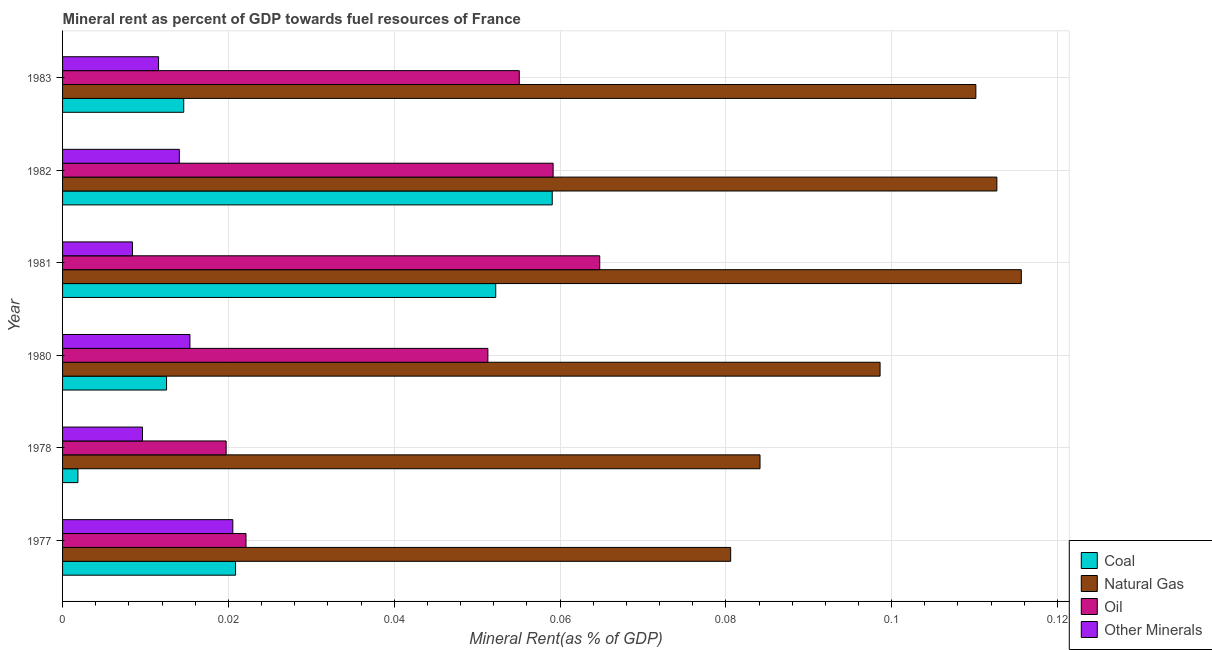How many groups of bars are there?
Provide a short and direct response. 6. Are the number of bars per tick equal to the number of legend labels?
Your response must be concise. Yes. Are the number of bars on each tick of the Y-axis equal?
Your response must be concise. Yes. How many bars are there on the 4th tick from the top?
Your response must be concise. 4. How many bars are there on the 4th tick from the bottom?
Your answer should be compact. 4. What is the oil rent in 1983?
Provide a succinct answer. 0.06. Across all years, what is the maximum coal rent?
Your answer should be very brief. 0.06. Across all years, what is the minimum natural gas rent?
Your response must be concise. 0.08. In which year was the natural gas rent maximum?
Provide a short and direct response. 1981. In which year was the oil rent minimum?
Provide a short and direct response. 1978. What is the total  rent of other minerals in the graph?
Offer a terse response. 0.08. What is the difference between the oil rent in 1977 and that in 1982?
Make the answer very short. -0.04. What is the difference between the oil rent in 1980 and the coal rent in 1983?
Provide a short and direct response. 0.04. What is the average oil rent per year?
Your response must be concise. 0.04. In the year 1983, what is the difference between the  rent of other minerals and oil rent?
Your response must be concise. -0.04. What is the ratio of the coal rent in 1982 to that in 1983?
Ensure brevity in your answer.  4.04. Is the coal rent in 1980 less than that in 1982?
Give a very brief answer. Yes. Is the difference between the oil rent in 1982 and 1983 greater than the difference between the natural gas rent in 1982 and 1983?
Your answer should be compact. Yes. What is the difference between the highest and the second highest natural gas rent?
Your response must be concise. 0. Is it the case that in every year, the sum of the oil rent and natural gas rent is greater than the sum of coal rent and  rent of other minerals?
Make the answer very short. No. What does the 3rd bar from the top in 1980 represents?
Provide a succinct answer. Natural Gas. What does the 1st bar from the bottom in 1980 represents?
Your response must be concise. Coal. Is it the case that in every year, the sum of the coal rent and natural gas rent is greater than the oil rent?
Your answer should be compact. Yes. How many bars are there?
Your response must be concise. 24. What is the difference between two consecutive major ticks on the X-axis?
Provide a short and direct response. 0.02. Are the values on the major ticks of X-axis written in scientific E-notation?
Provide a succinct answer. No. Does the graph contain grids?
Your response must be concise. Yes. Where does the legend appear in the graph?
Offer a very short reply. Bottom right. How many legend labels are there?
Make the answer very short. 4. How are the legend labels stacked?
Give a very brief answer. Vertical. What is the title of the graph?
Give a very brief answer. Mineral rent as percent of GDP towards fuel resources of France. Does "UNRWA" appear as one of the legend labels in the graph?
Keep it short and to the point. No. What is the label or title of the X-axis?
Offer a very short reply. Mineral Rent(as % of GDP). What is the Mineral Rent(as % of GDP) of Coal in 1977?
Your answer should be compact. 0.02. What is the Mineral Rent(as % of GDP) of Natural Gas in 1977?
Provide a short and direct response. 0.08. What is the Mineral Rent(as % of GDP) of Oil in 1977?
Give a very brief answer. 0.02. What is the Mineral Rent(as % of GDP) in Other Minerals in 1977?
Provide a succinct answer. 0.02. What is the Mineral Rent(as % of GDP) of Coal in 1978?
Your answer should be very brief. 0. What is the Mineral Rent(as % of GDP) of Natural Gas in 1978?
Provide a short and direct response. 0.08. What is the Mineral Rent(as % of GDP) of Oil in 1978?
Your response must be concise. 0.02. What is the Mineral Rent(as % of GDP) in Other Minerals in 1978?
Provide a short and direct response. 0.01. What is the Mineral Rent(as % of GDP) in Coal in 1980?
Offer a terse response. 0.01. What is the Mineral Rent(as % of GDP) in Natural Gas in 1980?
Offer a very short reply. 0.1. What is the Mineral Rent(as % of GDP) of Oil in 1980?
Provide a succinct answer. 0.05. What is the Mineral Rent(as % of GDP) of Other Minerals in 1980?
Your answer should be compact. 0.02. What is the Mineral Rent(as % of GDP) of Coal in 1981?
Provide a succinct answer. 0.05. What is the Mineral Rent(as % of GDP) in Natural Gas in 1981?
Give a very brief answer. 0.12. What is the Mineral Rent(as % of GDP) in Oil in 1981?
Your answer should be very brief. 0.06. What is the Mineral Rent(as % of GDP) of Other Minerals in 1981?
Your answer should be compact. 0.01. What is the Mineral Rent(as % of GDP) of Coal in 1982?
Offer a terse response. 0.06. What is the Mineral Rent(as % of GDP) of Natural Gas in 1982?
Your answer should be very brief. 0.11. What is the Mineral Rent(as % of GDP) in Oil in 1982?
Offer a terse response. 0.06. What is the Mineral Rent(as % of GDP) of Other Minerals in 1982?
Your answer should be compact. 0.01. What is the Mineral Rent(as % of GDP) in Coal in 1983?
Offer a very short reply. 0.01. What is the Mineral Rent(as % of GDP) of Natural Gas in 1983?
Your answer should be compact. 0.11. What is the Mineral Rent(as % of GDP) in Oil in 1983?
Your response must be concise. 0.06. What is the Mineral Rent(as % of GDP) of Other Minerals in 1983?
Provide a short and direct response. 0.01. Across all years, what is the maximum Mineral Rent(as % of GDP) in Coal?
Keep it short and to the point. 0.06. Across all years, what is the maximum Mineral Rent(as % of GDP) of Natural Gas?
Offer a very short reply. 0.12. Across all years, what is the maximum Mineral Rent(as % of GDP) of Oil?
Make the answer very short. 0.06. Across all years, what is the maximum Mineral Rent(as % of GDP) in Other Minerals?
Provide a short and direct response. 0.02. Across all years, what is the minimum Mineral Rent(as % of GDP) of Coal?
Your answer should be very brief. 0. Across all years, what is the minimum Mineral Rent(as % of GDP) in Natural Gas?
Ensure brevity in your answer.  0.08. Across all years, what is the minimum Mineral Rent(as % of GDP) in Oil?
Offer a terse response. 0.02. Across all years, what is the minimum Mineral Rent(as % of GDP) in Other Minerals?
Provide a succinct answer. 0.01. What is the total Mineral Rent(as % of GDP) in Coal in the graph?
Give a very brief answer. 0.16. What is the total Mineral Rent(as % of GDP) of Natural Gas in the graph?
Ensure brevity in your answer.  0.6. What is the total Mineral Rent(as % of GDP) in Oil in the graph?
Give a very brief answer. 0.27. What is the total Mineral Rent(as % of GDP) in Other Minerals in the graph?
Your response must be concise. 0.08. What is the difference between the Mineral Rent(as % of GDP) of Coal in 1977 and that in 1978?
Keep it short and to the point. 0.02. What is the difference between the Mineral Rent(as % of GDP) in Natural Gas in 1977 and that in 1978?
Your answer should be compact. -0. What is the difference between the Mineral Rent(as % of GDP) in Oil in 1977 and that in 1978?
Offer a very short reply. 0. What is the difference between the Mineral Rent(as % of GDP) in Other Minerals in 1977 and that in 1978?
Ensure brevity in your answer.  0.01. What is the difference between the Mineral Rent(as % of GDP) of Coal in 1977 and that in 1980?
Offer a very short reply. 0.01. What is the difference between the Mineral Rent(as % of GDP) in Natural Gas in 1977 and that in 1980?
Keep it short and to the point. -0.02. What is the difference between the Mineral Rent(as % of GDP) of Oil in 1977 and that in 1980?
Offer a terse response. -0.03. What is the difference between the Mineral Rent(as % of GDP) in Other Minerals in 1977 and that in 1980?
Offer a terse response. 0.01. What is the difference between the Mineral Rent(as % of GDP) in Coal in 1977 and that in 1981?
Provide a succinct answer. -0.03. What is the difference between the Mineral Rent(as % of GDP) of Natural Gas in 1977 and that in 1981?
Make the answer very short. -0.04. What is the difference between the Mineral Rent(as % of GDP) in Oil in 1977 and that in 1981?
Make the answer very short. -0.04. What is the difference between the Mineral Rent(as % of GDP) of Other Minerals in 1977 and that in 1981?
Your answer should be very brief. 0.01. What is the difference between the Mineral Rent(as % of GDP) in Coal in 1977 and that in 1982?
Your answer should be very brief. -0.04. What is the difference between the Mineral Rent(as % of GDP) of Natural Gas in 1977 and that in 1982?
Offer a very short reply. -0.03. What is the difference between the Mineral Rent(as % of GDP) of Oil in 1977 and that in 1982?
Ensure brevity in your answer.  -0.04. What is the difference between the Mineral Rent(as % of GDP) of Other Minerals in 1977 and that in 1982?
Keep it short and to the point. 0.01. What is the difference between the Mineral Rent(as % of GDP) in Coal in 1977 and that in 1983?
Offer a very short reply. 0.01. What is the difference between the Mineral Rent(as % of GDP) of Natural Gas in 1977 and that in 1983?
Make the answer very short. -0.03. What is the difference between the Mineral Rent(as % of GDP) in Oil in 1977 and that in 1983?
Make the answer very short. -0.03. What is the difference between the Mineral Rent(as % of GDP) in Other Minerals in 1977 and that in 1983?
Your answer should be very brief. 0.01. What is the difference between the Mineral Rent(as % of GDP) in Coal in 1978 and that in 1980?
Your response must be concise. -0.01. What is the difference between the Mineral Rent(as % of GDP) of Natural Gas in 1978 and that in 1980?
Ensure brevity in your answer.  -0.01. What is the difference between the Mineral Rent(as % of GDP) of Oil in 1978 and that in 1980?
Ensure brevity in your answer.  -0.03. What is the difference between the Mineral Rent(as % of GDP) of Other Minerals in 1978 and that in 1980?
Offer a very short reply. -0.01. What is the difference between the Mineral Rent(as % of GDP) of Coal in 1978 and that in 1981?
Your answer should be compact. -0.05. What is the difference between the Mineral Rent(as % of GDP) of Natural Gas in 1978 and that in 1981?
Give a very brief answer. -0.03. What is the difference between the Mineral Rent(as % of GDP) in Oil in 1978 and that in 1981?
Give a very brief answer. -0.05. What is the difference between the Mineral Rent(as % of GDP) in Other Minerals in 1978 and that in 1981?
Provide a succinct answer. 0. What is the difference between the Mineral Rent(as % of GDP) of Coal in 1978 and that in 1982?
Provide a short and direct response. -0.06. What is the difference between the Mineral Rent(as % of GDP) in Natural Gas in 1978 and that in 1982?
Provide a succinct answer. -0.03. What is the difference between the Mineral Rent(as % of GDP) in Oil in 1978 and that in 1982?
Your response must be concise. -0.04. What is the difference between the Mineral Rent(as % of GDP) of Other Minerals in 1978 and that in 1982?
Your answer should be compact. -0. What is the difference between the Mineral Rent(as % of GDP) in Coal in 1978 and that in 1983?
Give a very brief answer. -0.01. What is the difference between the Mineral Rent(as % of GDP) of Natural Gas in 1978 and that in 1983?
Your response must be concise. -0.03. What is the difference between the Mineral Rent(as % of GDP) of Oil in 1978 and that in 1983?
Your answer should be very brief. -0.04. What is the difference between the Mineral Rent(as % of GDP) of Other Minerals in 1978 and that in 1983?
Your response must be concise. -0. What is the difference between the Mineral Rent(as % of GDP) of Coal in 1980 and that in 1981?
Keep it short and to the point. -0.04. What is the difference between the Mineral Rent(as % of GDP) in Natural Gas in 1980 and that in 1981?
Make the answer very short. -0.02. What is the difference between the Mineral Rent(as % of GDP) of Oil in 1980 and that in 1981?
Provide a short and direct response. -0.01. What is the difference between the Mineral Rent(as % of GDP) in Other Minerals in 1980 and that in 1981?
Provide a succinct answer. 0.01. What is the difference between the Mineral Rent(as % of GDP) of Coal in 1980 and that in 1982?
Ensure brevity in your answer.  -0.05. What is the difference between the Mineral Rent(as % of GDP) in Natural Gas in 1980 and that in 1982?
Provide a succinct answer. -0.01. What is the difference between the Mineral Rent(as % of GDP) in Oil in 1980 and that in 1982?
Ensure brevity in your answer.  -0.01. What is the difference between the Mineral Rent(as % of GDP) in Other Minerals in 1980 and that in 1982?
Your response must be concise. 0. What is the difference between the Mineral Rent(as % of GDP) of Coal in 1980 and that in 1983?
Make the answer very short. -0. What is the difference between the Mineral Rent(as % of GDP) in Natural Gas in 1980 and that in 1983?
Provide a short and direct response. -0.01. What is the difference between the Mineral Rent(as % of GDP) in Oil in 1980 and that in 1983?
Make the answer very short. -0. What is the difference between the Mineral Rent(as % of GDP) in Other Minerals in 1980 and that in 1983?
Ensure brevity in your answer.  0. What is the difference between the Mineral Rent(as % of GDP) in Coal in 1981 and that in 1982?
Your answer should be compact. -0.01. What is the difference between the Mineral Rent(as % of GDP) in Natural Gas in 1981 and that in 1982?
Give a very brief answer. 0. What is the difference between the Mineral Rent(as % of GDP) of Oil in 1981 and that in 1982?
Make the answer very short. 0.01. What is the difference between the Mineral Rent(as % of GDP) in Other Minerals in 1981 and that in 1982?
Provide a short and direct response. -0.01. What is the difference between the Mineral Rent(as % of GDP) of Coal in 1981 and that in 1983?
Offer a terse response. 0.04. What is the difference between the Mineral Rent(as % of GDP) in Natural Gas in 1981 and that in 1983?
Ensure brevity in your answer.  0.01. What is the difference between the Mineral Rent(as % of GDP) in Oil in 1981 and that in 1983?
Your answer should be compact. 0.01. What is the difference between the Mineral Rent(as % of GDP) in Other Minerals in 1981 and that in 1983?
Offer a terse response. -0. What is the difference between the Mineral Rent(as % of GDP) in Coal in 1982 and that in 1983?
Make the answer very short. 0.04. What is the difference between the Mineral Rent(as % of GDP) of Natural Gas in 1982 and that in 1983?
Offer a very short reply. 0. What is the difference between the Mineral Rent(as % of GDP) of Oil in 1982 and that in 1983?
Provide a succinct answer. 0. What is the difference between the Mineral Rent(as % of GDP) in Other Minerals in 1982 and that in 1983?
Offer a very short reply. 0. What is the difference between the Mineral Rent(as % of GDP) in Coal in 1977 and the Mineral Rent(as % of GDP) in Natural Gas in 1978?
Keep it short and to the point. -0.06. What is the difference between the Mineral Rent(as % of GDP) of Coal in 1977 and the Mineral Rent(as % of GDP) of Oil in 1978?
Offer a very short reply. 0. What is the difference between the Mineral Rent(as % of GDP) in Coal in 1977 and the Mineral Rent(as % of GDP) in Other Minerals in 1978?
Keep it short and to the point. 0.01. What is the difference between the Mineral Rent(as % of GDP) of Natural Gas in 1977 and the Mineral Rent(as % of GDP) of Oil in 1978?
Give a very brief answer. 0.06. What is the difference between the Mineral Rent(as % of GDP) of Natural Gas in 1977 and the Mineral Rent(as % of GDP) of Other Minerals in 1978?
Your response must be concise. 0.07. What is the difference between the Mineral Rent(as % of GDP) in Oil in 1977 and the Mineral Rent(as % of GDP) in Other Minerals in 1978?
Provide a succinct answer. 0.01. What is the difference between the Mineral Rent(as % of GDP) in Coal in 1977 and the Mineral Rent(as % of GDP) in Natural Gas in 1980?
Provide a short and direct response. -0.08. What is the difference between the Mineral Rent(as % of GDP) in Coal in 1977 and the Mineral Rent(as % of GDP) in Oil in 1980?
Offer a very short reply. -0.03. What is the difference between the Mineral Rent(as % of GDP) in Coal in 1977 and the Mineral Rent(as % of GDP) in Other Minerals in 1980?
Your answer should be very brief. 0.01. What is the difference between the Mineral Rent(as % of GDP) of Natural Gas in 1977 and the Mineral Rent(as % of GDP) of Oil in 1980?
Offer a very short reply. 0.03. What is the difference between the Mineral Rent(as % of GDP) of Natural Gas in 1977 and the Mineral Rent(as % of GDP) of Other Minerals in 1980?
Make the answer very short. 0.07. What is the difference between the Mineral Rent(as % of GDP) of Oil in 1977 and the Mineral Rent(as % of GDP) of Other Minerals in 1980?
Offer a very short reply. 0.01. What is the difference between the Mineral Rent(as % of GDP) in Coal in 1977 and the Mineral Rent(as % of GDP) in Natural Gas in 1981?
Provide a short and direct response. -0.09. What is the difference between the Mineral Rent(as % of GDP) in Coal in 1977 and the Mineral Rent(as % of GDP) in Oil in 1981?
Your response must be concise. -0.04. What is the difference between the Mineral Rent(as % of GDP) in Coal in 1977 and the Mineral Rent(as % of GDP) in Other Minerals in 1981?
Make the answer very short. 0.01. What is the difference between the Mineral Rent(as % of GDP) in Natural Gas in 1977 and the Mineral Rent(as % of GDP) in Oil in 1981?
Provide a succinct answer. 0.02. What is the difference between the Mineral Rent(as % of GDP) of Natural Gas in 1977 and the Mineral Rent(as % of GDP) of Other Minerals in 1981?
Your answer should be compact. 0.07. What is the difference between the Mineral Rent(as % of GDP) of Oil in 1977 and the Mineral Rent(as % of GDP) of Other Minerals in 1981?
Give a very brief answer. 0.01. What is the difference between the Mineral Rent(as % of GDP) in Coal in 1977 and the Mineral Rent(as % of GDP) in Natural Gas in 1982?
Your answer should be compact. -0.09. What is the difference between the Mineral Rent(as % of GDP) in Coal in 1977 and the Mineral Rent(as % of GDP) in Oil in 1982?
Keep it short and to the point. -0.04. What is the difference between the Mineral Rent(as % of GDP) of Coal in 1977 and the Mineral Rent(as % of GDP) of Other Minerals in 1982?
Offer a terse response. 0.01. What is the difference between the Mineral Rent(as % of GDP) of Natural Gas in 1977 and the Mineral Rent(as % of GDP) of Oil in 1982?
Give a very brief answer. 0.02. What is the difference between the Mineral Rent(as % of GDP) of Natural Gas in 1977 and the Mineral Rent(as % of GDP) of Other Minerals in 1982?
Your response must be concise. 0.07. What is the difference between the Mineral Rent(as % of GDP) in Oil in 1977 and the Mineral Rent(as % of GDP) in Other Minerals in 1982?
Make the answer very short. 0.01. What is the difference between the Mineral Rent(as % of GDP) in Coal in 1977 and the Mineral Rent(as % of GDP) in Natural Gas in 1983?
Provide a succinct answer. -0.09. What is the difference between the Mineral Rent(as % of GDP) of Coal in 1977 and the Mineral Rent(as % of GDP) of Oil in 1983?
Your answer should be compact. -0.03. What is the difference between the Mineral Rent(as % of GDP) of Coal in 1977 and the Mineral Rent(as % of GDP) of Other Minerals in 1983?
Your answer should be compact. 0.01. What is the difference between the Mineral Rent(as % of GDP) in Natural Gas in 1977 and the Mineral Rent(as % of GDP) in Oil in 1983?
Keep it short and to the point. 0.03. What is the difference between the Mineral Rent(as % of GDP) of Natural Gas in 1977 and the Mineral Rent(as % of GDP) of Other Minerals in 1983?
Your answer should be compact. 0.07. What is the difference between the Mineral Rent(as % of GDP) of Oil in 1977 and the Mineral Rent(as % of GDP) of Other Minerals in 1983?
Make the answer very short. 0.01. What is the difference between the Mineral Rent(as % of GDP) in Coal in 1978 and the Mineral Rent(as % of GDP) in Natural Gas in 1980?
Ensure brevity in your answer.  -0.1. What is the difference between the Mineral Rent(as % of GDP) in Coal in 1978 and the Mineral Rent(as % of GDP) in Oil in 1980?
Give a very brief answer. -0.05. What is the difference between the Mineral Rent(as % of GDP) in Coal in 1978 and the Mineral Rent(as % of GDP) in Other Minerals in 1980?
Provide a short and direct response. -0.01. What is the difference between the Mineral Rent(as % of GDP) in Natural Gas in 1978 and the Mineral Rent(as % of GDP) in Oil in 1980?
Ensure brevity in your answer.  0.03. What is the difference between the Mineral Rent(as % of GDP) of Natural Gas in 1978 and the Mineral Rent(as % of GDP) of Other Minerals in 1980?
Provide a succinct answer. 0.07. What is the difference between the Mineral Rent(as % of GDP) in Oil in 1978 and the Mineral Rent(as % of GDP) in Other Minerals in 1980?
Your answer should be compact. 0. What is the difference between the Mineral Rent(as % of GDP) of Coal in 1978 and the Mineral Rent(as % of GDP) of Natural Gas in 1981?
Your answer should be compact. -0.11. What is the difference between the Mineral Rent(as % of GDP) of Coal in 1978 and the Mineral Rent(as % of GDP) of Oil in 1981?
Give a very brief answer. -0.06. What is the difference between the Mineral Rent(as % of GDP) of Coal in 1978 and the Mineral Rent(as % of GDP) of Other Minerals in 1981?
Ensure brevity in your answer.  -0.01. What is the difference between the Mineral Rent(as % of GDP) in Natural Gas in 1978 and the Mineral Rent(as % of GDP) in Oil in 1981?
Provide a succinct answer. 0.02. What is the difference between the Mineral Rent(as % of GDP) of Natural Gas in 1978 and the Mineral Rent(as % of GDP) of Other Minerals in 1981?
Make the answer very short. 0.08. What is the difference between the Mineral Rent(as % of GDP) of Oil in 1978 and the Mineral Rent(as % of GDP) of Other Minerals in 1981?
Ensure brevity in your answer.  0.01. What is the difference between the Mineral Rent(as % of GDP) in Coal in 1978 and the Mineral Rent(as % of GDP) in Natural Gas in 1982?
Offer a very short reply. -0.11. What is the difference between the Mineral Rent(as % of GDP) of Coal in 1978 and the Mineral Rent(as % of GDP) of Oil in 1982?
Provide a short and direct response. -0.06. What is the difference between the Mineral Rent(as % of GDP) in Coal in 1978 and the Mineral Rent(as % of GDP) in Other Minerals in 1982?
Offer a very short reply. -0.01. What is the difference between the Mineral Rent(as % of GDP) in Natural Gas in 1978 and the Mineral Rent(as % of GDP) in Oil in 1982?
Your response must be concise. 0.03. What is the difference between the Mineral Rent(as % of GDP) of Natural Gas in 1978 and the Mineral Rent(as % of GDP) of Other Minerals in 1982?
Give a very brief answer. 0.07. What is the difference between the Mineral Rent(as % of GDP) in Oil in 1978 and the Mineral Rent(as % of GDP) in Other Minerals in 1982?
Provide a succinct answer. 0.01. What is the difference between the Mineral Rent(as % of GDP) of Coal in 1978 and the Mineral Rent(as % of GDP) of Natural Gas in 1983?
Offer a very short reply. -0.11. What is the difference between the Mineral Rent(as % of GDP) of Coal in 1978 and the Mineral Rent(as % of GDP) of Oil in 1983?
Provide a succinct answer. -0.05. What is the difference between the Mineral Rent(as % of GDP) of Coal in 1978 and the Mineral Rent(as % of GDP) of Other Minerals in 1983?
Your response must be concise. -0.01. What is the difference between the Mineral Rent(as % of GDP) in Natural Gas in 1978 and the Mineral Rent(as % of GDP) in Oil in 1983?
Your answer should be very brief. 0.03. What is the difference between the Mineral Rent(as % of GDP) in Natural Gas in 1978 and the Mineral Rent(as % of GDP) in Other Minerals in 1983?
Ensure brevity in your answer.  0.07. What is the difference between the Mineral Rent(as % of GDP) of Oil in 1978 and the Mineral Rent(as % of GDP) of Other Minerals in 1983?
Keep it short and to the point. 0.01. What is the difference between the Mineral Rent(as % of GDP) of Coal in 1980 and the Mineral Rent(as % of GDP) of Natural Gas in 1981?
Ensure brevity in your answer.  -0.1. What is the difference between the Mineral Rent(as % of GDP) in Coal in 1980 and the Mineral Rent(as % of GDP) in Oil in 1981?
Give a very brief answer. -0.05. What is the difference between the Mineral Rent(as % of GDP) of Coal in 1980 and the Mineral Rent(as % of GDP) of Other Minerals in 1981?
Your answer should be compact. 0. What is the difference between the Mineral Rent(as % of GDP) in Natural Gas in 1980 and the Mineral Rent(as % of GDP) in Oil in 1981?
Your answer should be compact. 0.03. What is the difference between the Mineral Rent(as % of GDP) of Natural Gas in 1980 and the Mineral Rent(as % of GDP) of Other Minerals in 1981?
Your answer should be compact. 0.09. What is the difference between the Mineral Rent(as % of GDP) in Oil in 1980 and the Mineral Rent(as % of GDP) in Other Minerals in 1981?
Your response must be concise. 0.04. What is the difference between the Mineral Rent(as % of GDP) of Coal in 1980 and the Mineral Rent(as % of GDP) of Natural Gas in 1982?
Ensure brevity in your answer.  -0.1. What is the difference between the Mineral Rent(as % of GDP) of Coal in 1980 and the Mineral Rent(as % of GDP) of Oil in 1982?
Make the answer very short. -0.05. What is the difference between the Mineral Rent(as % of GDP) of Coal in 1980 and the Mineral Rent(as % of GDP) of Other Minerals in 1982?
Offer a terse response. -0. What is the difference between the Mineral Rent(as % of GDP) of Natural Gas in 1980 and the Mineral Rent(as % of GDP) of Oil in 1982?
Ensure brevity in your answer.  0.04. What is the difference between the Mineral Rent(as % of GDP) of Natural Gas in 1980 and the Mineral Rent(as % of GDP) of Other Minerals in 1982?
Your answer should be very brief. 0.08. What is the difference between the Mineral Rent(as % of GDP) of Oil in 1980 and the Mineral Rent(as % of GDP) of Other Minerals in 1982?
Give a very brief answer. 0.04. What is the difference between the Mineral Rent(as % of GDP) in Coal in 1980 and the Mineral Rent(as % of GDP) in Natural Gas in 1983?
Your answer should be compact. -0.1. What is the difference between the Mineral Rent(as % of GDP) of Coal in 1980 and the Mineral Rent(as % of GDP) of Oil in 1983?
Provide a succinct answer. -0.04. What is the difference between the Mineral Rent(as % of GDP) in Natural Gas in 1980 and the Mineral Rent(as % of GDP) in Oil in 1983?
Offer a very short reply. 0.04. What is the difference between the Mineral Rent(as % of GDP) in Natural Gas in 1980 and the Mineral Rent(as % of GDP) in Other Minerals in 1983?
Offer a very short reply. 0.09. What is the difference between the Mineral Rent(as % of GDP) of Oil in 1980 and the Mineral Rent(as % of GDP) of Other Minerals in 1983?
Your answer should be very brief. 0.04. What is the difference between the Mineral Rent(as % of GDP) in Coal in 1981 and the Mineral Rent(as % of GDP) in Natural Gas in 1982?
Your response must be concise. -0.06. What is the difference between the Mineral Rent(as % of GDP) in Coal in 1981 and the Mineral Rent(as % of GDP) in Oil in 1982?
Give a very brief answer. -0.01. What is the difference between the Mineral Rent(as % of GDP) of Coal in 1981 and the Mineral Rent(as % of GDP) of Other Minerals in 1982?
Offer a very short reply. 0.04. What is the difference between the Mineral Rent(as % of GDP) in Natural Gas in 1981 and the Mineral Rent(as % of GDP) in Oil in 1982?
Offer a terse response. 0.06. What is the difference between the Mineral Rent(as % of GDP) of Natural Gas in 1981 and the Mineral Rent(as % of GDP) of Other Minerals in 1982?
Your response must be concise. 0.1. What is the difference between the Mineral Rent(as % of GDP) of Oil in 1981 and the Mineral Rent(as % of GDP) of Other Minerals in 1982?
Give a very brief answer. 0.05. What is the difference between the Mineral Rent(as % of GDP) in Coal in 1981 and the Mineral Rent(as % of GDP) in Natural Gas in 1983?
Offer a terse response. -0.06. What is the difference between the Mineral Rent(as % of GDP) of Coal in 1981 and the Mineral Rent(as % of GDP) of Oil in 1983?
Your answer should be compact. -0. What is the difference between the Mineral Rent(as % of GDP) in Coal in 1981 and the Mineral Rent(as % of GDP) in Other Minerals in 1983?
Provide a succinct answer. 0.04. What is the difference between the Mineral Rent(as % of GDP) in Natural Gas in 1981 and the Mineral Rent(as % of GDP) in Oil in 1983?
Your answer should be very brief. 0.06. What is the difference between the Mineral Rent(as % of GDP) of Natural Gas in 1981 and the Mineral Rent(as % of GDP) of Other Minerals in 1983?
Offer a terse response. 0.1. What is the difference between the Mineral Rent(as % of GDP) of Oil in 1981 and the Mineral Rent(as % of GDP) of Other Minerals in 1983?
Your answer should be compact. 0.05. What is the difference between the Mineral Rent(as % of GDP) of Coal in 1982 and the Mineral Rent(as % of GDP) of Natural Gas in 1983?
Provide a short and direct response. -0.05. What is the difference between the Mineral Rent(as % of GDP) in Coal in 1982 and the Mineral Rent(as % of GDP) in Oil in 1983?
Keep it short and to the point. 0. What is the difference between the Mineral Rent(as % of GDP) in Coal in 1982 and the Mineral Rent(as % of GDP) in Other Minerals in 1983?
Your answer should be very brief. 0.05. What is the difference between the Mineral Rent(as % of GDP) in Natural Gas in 1982 and the Mineral Rent(as % of GDP) in Oil in 1983?
Give a very brief answer. 0.06. What is the difference between the Mineral Rent(as % of GDP) in Natural Gas in 1982 and the Mineral Rent(as % of GDP) in Other Minerals in 1983?
Provide a short and direct response. 0.1. What is the difference between the Mineral Rent(as % of GDP) of Oil in 1982 and the Mineral Rent(as % of GDP) of Other Minerals in 1983?
Your answer should be very brief. 0.05. What is the average Mineral Rent(as % of GDP) of Coal per year?
Offer a terse response. 0.03. What is the average Mineral Rent(as % of GDP) of Natural Gas per year?
Your answer should be very brief. 0.1. What is the average Mineral Rent(as % of GDP) of Oil per year?
Your response must be concise. 0.05. What is the average Mineral Rent(as % of GDP) of Other Minerals per year?
Give a very brief answer. 0.01. In the year 1977, what is the difference between the Mineral Rent(as % of GDP) of Coal and Mineral Rent(as % of GDP) of Natural Gas?
Offer a very short reply. -0.06. In the year 1977, what is the difference between the Mineral Rent(as % of GDP) of Coal and Mineral Rent(as % of GDP) of Oil?
Your answer should be very brief. -0. In the year 1977, what is the difference between the Mineral Rent(as % of GDP) in Natural Gas and Mineral Rent(as % of GDP) in Oil?
Your answer should be compact. 0.06. In the year 1977, what is the difference between the Mineral Rent(as % of GDP) in Natural Gas and Mineral Rent(as % of GDP) in Other Minerals?
Ensure brevity in your answer.  0.06. In the year 1977, what is the difference between the Mineral Rent(as % of GDP) in Oil and Mineral Rent(as % of GDP) in Other Minerals?
Your answer should be compact. 0. In the year 1978, what is the difference between the Mineral Rent(as % of GDP) in Coal and Mineral Rent(as % of GDP) in Natural Gas?
Make the answer very short. -0.08. In the year 1978, what is the difference between the Mineral Rent(as % of GDP) of Coal and Mineral Rent(as % of GDP) of Oil?
Your answer should be compact. -0.02. In the year 1978, what is the difference between the Mineral Rent(as % of GDP) of Coal and Mineral Rent(as % of GDP) of Other Minerals?
Provide a succinct answer. -0.01. In the year 1978, what is the difference between the Mineral Rent(as % of GDP) of Natural Gas and Mineral Rent(as % of GDP) of Oil?
Ensure brevity in your answer.  0.06. In the year 1978, what is the difference between the Mineral Rent(as % of GDP) of Natural Gas and Mineral Rent(as % of GDP) of Other Minerals?
Keep it short and to the point. 0.07. In the year 1978, what is the difference between the Mineral Rent(as % of GDP) of Oil and Mineral Rent(as % of GDP) of Other Minerals?
Your response must be concise. 0.01. In the year 1980, what is the difference between the Mineral Rent(as % of GDP) in Coal and Mineral Rent(as % of GDP) in Natural Gas?
Offer a very short reply. -0.09. In the year 1980, what is the difference between the Mineral Rent(as % of GDP) of Coal and Mineral Rent(as % of GDP) of Oil?
Make the answer very short. -0.04. In the year 1980, what is the difference between the Mineral Rent(as % of GDP) of Coal and Mineral Rent(as % of GDP) of Other Minerals?
Provide a short and direct response. -0. In the year 1980, what is the difference between the Mineral Rent(as % of GDP) in Natural Gas and Mineral Rent(as % of GDP) in Oil?
Your answer should be very brief. 0.05. In the year 1980, what is the difference between the Mineral Rent(as % of GDP) of Natural Gas and Mineral Rent(as % of GDP) of Other Minerals?
Ensure brevity in your answer.  0.08. In the year 1980, what is the difference between the Mineral Rent(as % of GDP) in Oil and Mineral Rent(as % of GDP) in Other Minerals?
Your response must be concise. 0.04. In the year 1981, what is the difference between the Mineral Rent(as % of GDP) of Coal and Mineral Rent(as % of GDP) of Natural Gas?
Offer a terse response. -0.06. In the year 1981, what is the difference between the Mineral Rent(as % of GDP) of Coal and Mineral Rent(as % of GDP) of Oil?
Ensure brevity in your answer.  -0.01. In the year 1981, what is the difference between the Mineral Rent(as % of GDP) of Coal and Mineral Rent(as % of GDP) of Other Minerals?
Offer a terse response. 0.04. In the year 1981, what is the difference between the Mineral Rent(as % of GDP) in Natural Gas and Mineral Rent(as % of GDP) in Oil?
Provide a short and direct response. 0.05. In the year 1981, what is the difference between the Mineral Rent(as % of GDP) in Natural Gas and Mineral Rent(as % of GDP) in Other Minerals?
Your answer should be compact. 0.11. In the year 1981, what is the difference between the Mineral Rent(as % of GDP) of Oil and Mineral Rent(as % of GDP) of Other Minerals?
Your response must be concise. 0.06. In the year 1982, what is the difference between the Mineral Rent(as % of GDP) of Coal and Mineral Rent(as % of GDP) of Natural Gas?
Offer a very short reply. -0.05. In the year 1982, what is the difference between the Mineral Rent(as % of GDP) in Coal and Mineral Rent(as % of GDP) in Oil?
Your answer should be compact. -0. In the year 1982, what is the difference between the Mineral Rent(as % of GDP) of Coal and Mineral Rent(as % of GDP) of Other Minerals?
Your answer should be compact. 0.04. In the year 1982, what is the difference between the Mineral Rent(as % of GDP) of Natural Gas and Mineral Rent(as % of GDP) of Oil?
Give a very brief answer. 0.05. In the year 1982, what is the difference between the Mineral Rent(as % of GDP) of Natural Gas and Mineral Rent(as % of GDP) of Other Minerals?
Provide a succinct answer. 0.1. In the year 1982, what is the difference between the Mineral Rent(as % of GDP) in Oil and Mineral Rent(as % of GDP) in Other Minerals?
Your response must be concise. 0.05. In the year 1983, what is the difference between the Mineral Rent(as % of GDP) of Coal and Mineral Rent(as % of GDP) of Natural Gas?
Offer a terse response. -0.1. In the year 1983, what is the difference between the Mineral Rent(as % of GDP) of Coal and Mineral Rent(as % of GDP) of Oil?
Keep it short and to the point. -0.04. In the year 1983, what is the difference between the Mineral Rent(as % of GDP) in Coal and Mineral Rent(as % of GDP) in Other Minerals?
Your answer should be compact. 0. In the year 1983, what is the difference between the Mineral Rent(as % of GDP) in Natural Gas and Mineral Rent(as % of GDP) in Oil?
Provide a short and direct response. 0.06. In the year 1983, what is the difference between the Mineral Rent(as % of GDP) in Natural Gas and Mineral Rent(as % of GDP) in Other Minerals?
Ensure brevity in your answer.  0.1. In the year 1983, what is the difference between the Mineral Rent(as % of GDP) of Oil and Mineral Rent(as % of GDP) of Other Minerals?
Ensure brevity in your answer.  0.04. What is the ratio of the Mineral Rent(as % of GDP) of Coal in 1977 to that in 1978?
Keep it short and to the point. 11.27. What is the ratio of the Mineral Rent(as % of GDP) of Natural Gas in 1977 to that in 1978?
Offer a very short reply. 0.96. What is the ratio of the Mineral Rent(as % of GDP) of Oil in 1977 to that in 1978?
Keep it short and to the point. 1.12. What is the ratio of the Mineral Rent(as % of GDP) in Other Minerals in 1977 to that in 1978?
Provide a succinct answer. 2.13. What is the ratio of the Mineral Rent(as % of GDP) of Coal in 1977 to that in 1980?
Your response must be concise. 1.66. What is the ratio of the Mineral Rent(as % of GDP) of Natural Gas in 1977 to that in 1980?
Make the answer very short. 0.82. What is the ratio of the Mineral Rent(as % of GDP) in Oil in 1977 to that in 1980?
Offer a very short reply. 0.43. What is the ratio of the Mineral Rent(as % of GDP) of Other Minerals in 1977 to that in 1980?
Your answer should be compact. 1.34. What is the ratio of the Mineral Rent(as % of GDP) of Coal in 1977 to that in 1981?
Your response must be concise. 0.4. What is the ratio of the Mineral Rent(as % of GDP) in Natural Gas in 1977 to that in 1981?
Keep it short and to the point. 0.7. What is the ratio of the Mineral Rent(as % of GDP) in Oil in 1977 to that in 1981?
Provide a short and direct response. 0.34. What is the ratio of the Mineral Rent(as % of GDP) in Other Minerals in 1977 to that in 1981?
Your response must be concise. 2.44. What is the ratio of the Mineral Rent(as % of GDP) of Coal in 1977 to that in 1982?
Your response must be concise. 0.35. What is the ratio of the Mineral Rent(as % of GDP) in Natural Gas in 1977 to that in 1982?
Your answer should be very brief. 0.72. What is the ratio of the Mineral Rent(as % of GDP) in Oil in 1977 to that in 1982?
Make the answer very short. 0.37. What is the ratio of the Mineral Rent(as % of GDP) in Other Minerals in 1977 to that in 1982?
Make the answer very short. 1.46. What is the ratio of the Mineral Rent(as % of GDP) of Coal in 1977 to that in 1983?
Provide a short and direct response. 1.43. What is the ratio of the Mineral Rent(as % of GDP) of Natural Gas in 1977 to that in 1983?
Make the answer very short. 0.73. What is the ratio of the Mineral Rent(as % of GDP) of Oil in 1977 to that in 1983?
Your response must be concise. 0.4. What is the ratio of the Mineral Rent(as % of GDP) of Other Minerals in 1977 to that in 1983?
Offer a very short reply. 1.77. What is the ratio of the Mineral Rent(as % of GDP) of Coal in 1978 to that in 1980?
Your answer should be compact. 0.15. What is the ratio of the Mineral Rent(as % of GDP) of Natural Gas in 1978 to that in 1980?
Provide a short and direct response. 0.85. What is the ratio of the Mineral Rent(as % of GDP) of Oil in 1978 to that in 1980?
Provide a short and direct response. 0.38. What is the ratio of the Mineral Rent(as % of GDP) in Other Minerals in 1978 to that in 1980?
Your answer should be compact. 0.63. What is the ratio of the Mineral Rent(as % of GDP) of Coal in 1978 to that in 1981?
Your answer should be compact. 0.04. What is the ratio of the Mineral Rent(as % of GDP) in Natural Gas in 1978 to that in 1981?
Your answer should be very brief. 0.73. What is the ratio of the Mineral Rent(as % of GDP) in Oil in 1978 to that in 1981?
Offer a very short reply. 0.3. What is the ratio of the Mineral Rent(as % of GDP) in Other Minerals in 1978 to that in 1981?
Ensure brevity in your answer.  1.14. What is the ratio of the Mineral Rent(as % of GDP) in Coal in 1978 to that in 1982?
Offer a very short reply. 0.03. What is the ratio of the Mineral Rent(as % of GDP) of Natural Gas in 1978 to that in 1982?
Your answer should be very brief. 0.75. What is the ratio of the Mineral Rent(as % of GDP) of Oil in 1978 to that in 1982?
Ensure brevity in your answer.  0.33. What is the ratio of the Mineral Rent(as % of GDP) of Other Minerals in 1978 to that in 1982?
Give a very brief answer. 0.68. What is the ratio of the Mineral Rent(as % of GDP) in Coal in 1978 to that in 1983?
Your answer should be very brief. 0.13. What is the ratio of the Mineral Rent(as % of GDP) of Natural Gas in 1978 to that in 1983?
Offer a very short reply. 0.76. What is the ratio of the Mineral Rent(as % of GDP) in Oil in 1978 to that in 1983?
Provide a succinct answer. 0.36. What is the ratio of the Mineral Rent(as % of GDP) in Other Minerals in 1978 to that in 1983?
Keep it short and to the point. 0.83. What is the ratio of the Mineral Rent(as % of GDP) of Coal in 1980 to that in 1981?
Give a very brief answer. 0.24. What is the ratio of the Mineral Rent(as % of GDP) of Natural Gas in 1980 to that in 1981?
Offer a very short reply. 0.85. What is the ratio of the Mineral Rent(as % of GDP) in Oil in 1980 to that in 1981?
Make the answer very short. 0.79. What is the ratio of the Mineral Rent(as % of GDP) in Other Minerals in 1980 to that in 1981?
Give a very brief answer. 1.82. What is the ratio of the Mineral Rent(as % of GDP) of Coal in 1980 to that in 1982?
Your answer should be very brief. 0.21. What is the ratio of the Mineral Rent(as % of GDP) of Natural Gas in 1980 to that in 1982?
Keep it short and to the point. 0.88. What is the ratio of the Mineral Rent(as % of GDP) in Oil in 1980 to that in 1982?
Your answer should be compact. 0.87. What is the ratio of the Mineral Rent(as % of GDP) of Other Minerals in 1980 to that in 1982?
Give a very brief answer. 1.09. What is the ratio of the Mineral Rent(as % of GDP) in Coal in 1980 to that in 1983?
Provide a short and direct response. 0.86. What is the ratio of the Mineral Rent(as % of GDP) of Natural Gas in 1980 to that in 1983?
Provide a short and direct response. 0.9. What is the ratio of the Mineral Rent(as % of GDP) of Oil in 1980 to that in 1983?
Offer a very short reply. 0.93. What is the ratio of the Mineral Rent(as % of GDP) of Other Minerals in 1980 to that in 1983?
Offer a very short reply. 1.33. What is the ratio of the Mineral Rent(as % of GDP) in Coal in 1981 to that in 1982?
Keep it short and to the point. 0.88. What is the ratio of the Mineral Rent(as % of GDP) of Natural Gas in 1981 to that in 1982?
Your answer should be very brief. 1.03. What is the ratio of the Mineral Rent(as % of GDP) in Oil in 1981 to that in 1982?
Provide a short and direct response. 1.09. What is the ratio of the Mineral Rent(as % of GDP) in Other Minerals in 1981 to that in 1982?
Your answer should be compact. 0.6. What is the ratio of the Mineral Rent(as % of GDP) of Coal in 1981 to that in 1983?
Provide a short and direct response. 3.57. What is the ratio of the Mineral Rent(as % of GDP) in Natural Gas in 1981 to that in 1983?
Ensure brevity in your answer.  1.05. What is the ratio of the Mineral Rent(as % of GDP) of Oil in 1981 to that in 1983?
Your answer should be compact. 1.18. What is the ratio of the Mineral Rent(as % of GDP) in Other Minerals in 1981 to that in 1983?
Give a very brief answer. 0.73. What is the ratio of the Mineral Rent(as % of GDP) of Coal in 1982 to that in 1983?
Offer a very short reply. 4.04. What is the ratio of the Mineral Rent(as % of GDP) in Oil in 1982 to that in 1983?
Make the answer very short. 1.07. What is the ratio of the Mineral Rent(as % of GDP) of Other Minerals in 1982 to that in 1983?
Provide a short and direct response. 1.22. What is the difference between the highest and the second highest Mineral Rent(as % of GDP) of Coal?
Give a very brief answer. 0.01. What is the difference between the highest and the second highest Mineral Rent(as % of GDP) of Natural Gas?
Provide a short and direct response. 0. What is the difference between the highest and the second highest Mineral Rent(as % of GDP) of Oil?
Give a very brief answer. 0.01. What is the difference between the highest and the second highest Mineral Rent(as % of GDP) of Other Minerals?
Offer a very short reply. 0.01. What is the difference between the highest and the lowest Mineral Rent(as % of GDP) in Coal?
Your response must be concise. 0.06. What is the difference between the highest and the lowest Mineral Rent(as % of GDP) of Natural Gas?
Provide a succinct answer. 0.04. What is the difference between the highest and the lowest Mineral Rent(as % of GDP) of Oil?
Offer a terse response. 0.05. What is the difference between the highest and the lowest Mineral Rent(as % of GDP) in Other Minerals?
Offer a very short reply. 0.01. 